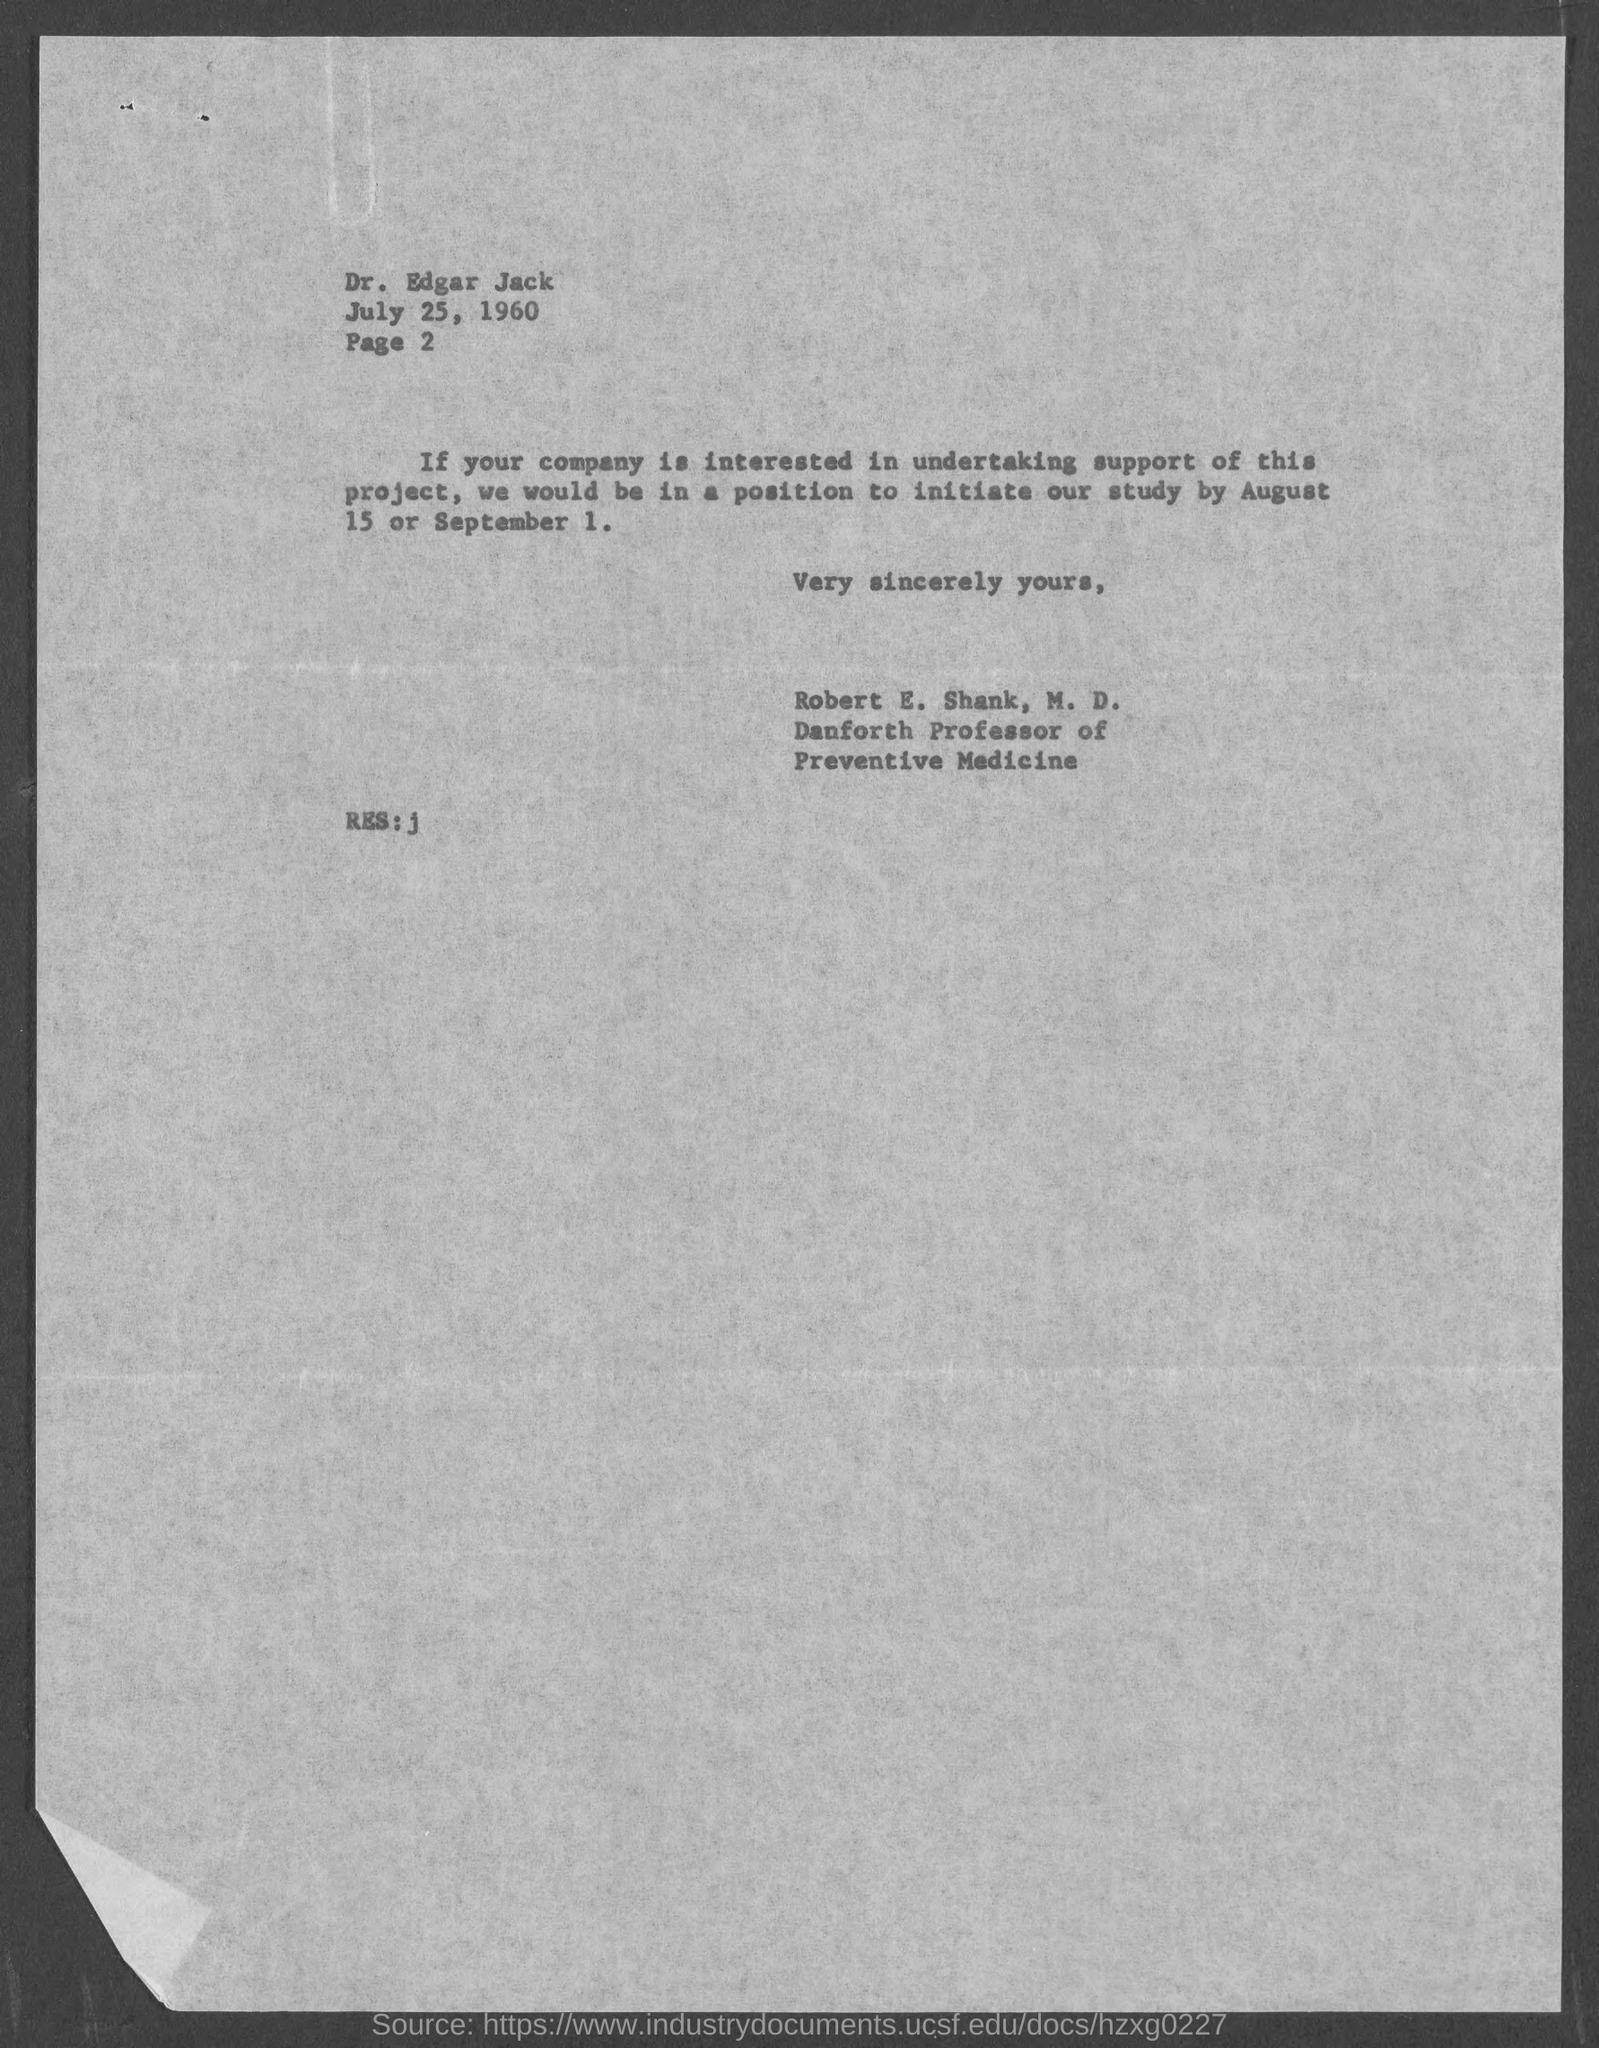Who wrote this letter?
Your response must be concise. Robert E. Shank, M.D. To whom this letter is written to?
Provide a succinct answer. Dr. Edgar Jack. Who is the danforth professor of preventive medicine?
Your answer should be compact. Robert E. Shank, M.D. When can this study be initiated by?
Provide a short and direct response. August 15 or september 1. What is page number mentioned under dr.edgar jack?
Ensure brevity in your answer.  2. 